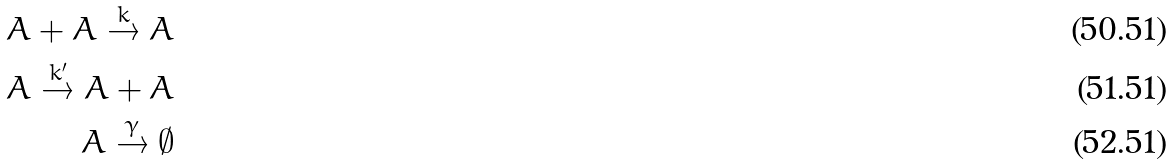<formula> <loc_0><loc_0><loc_500><loc_500>A + A \stackrel { k } { \rightarrow } A \\ A \stackrel { k ^ { \prime } } { \rightarrow } A + A \\ A \stackrel { \gamma } { \rightarrow } \emptyset</formula> 